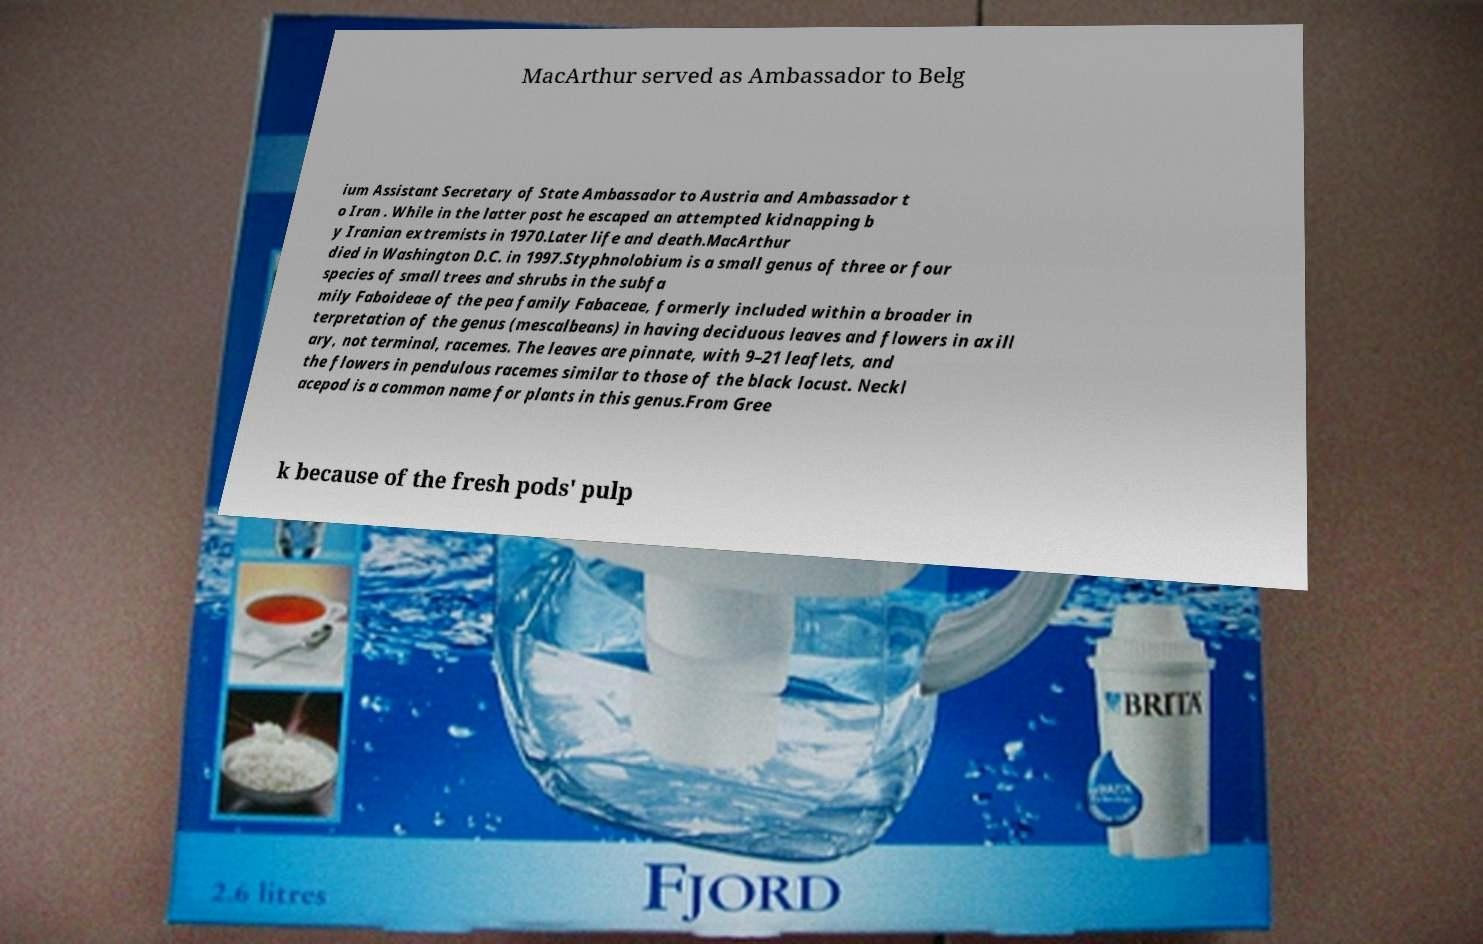There's text embedded in this image that I need extracted. Can you transcribe it verbatim? MacArthur served as Ambassador to Belg ium Assistant Secretary of State Ambassador to Austria and Ambassador t o Iran . While in the latter post he escaped an attempted kidnapping b y Iranian extremists in 1970.Later life and death.MacArthur died in Washington D.C. in 1997.Styphnolobium is a small genus of three or four species of small trees and shrubs in the subfa mily Faboideae of the pea family Fabaceae, formerly included within a broader in terpretation of the genus (mescalbeans) in having deciduous leaves and flowers in axill ary, not terminal, racemes. The leaves are pinnate, with 9–21 leaflets, and the flowers in pendulous racemes similar to those of the black locust. Neckl acepod is a common name for plants in this genus.From Gree k because of the fresh pods' pulp 